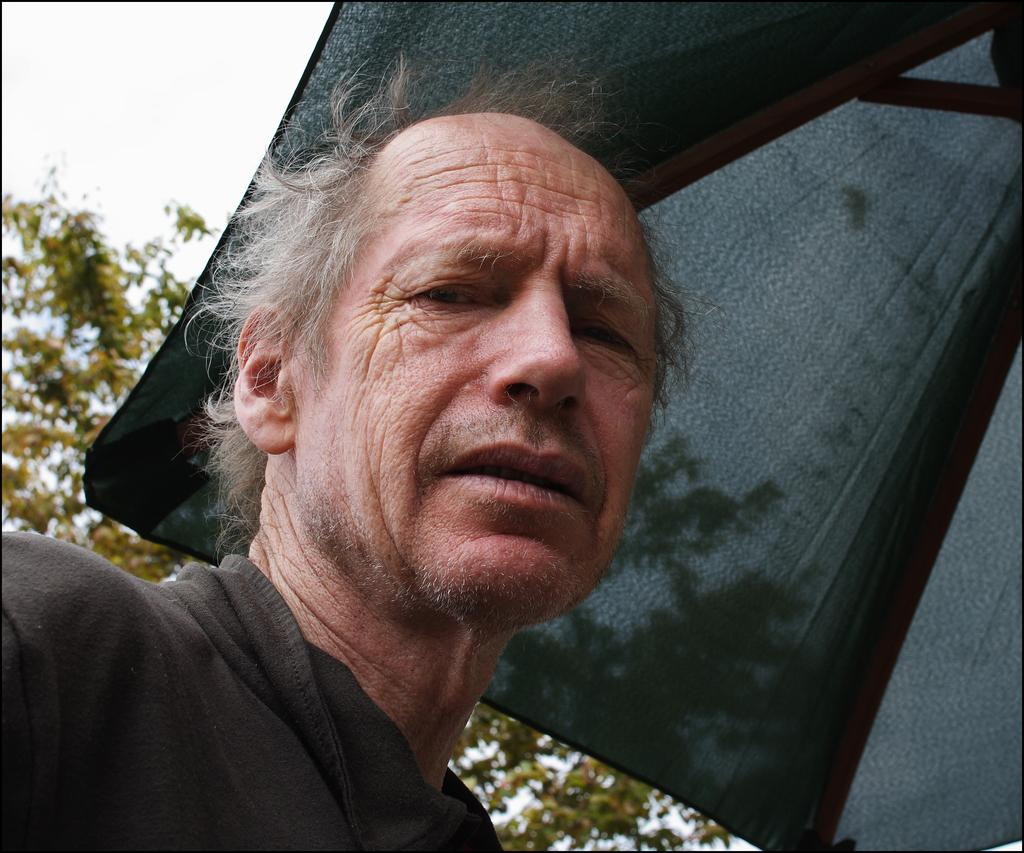Who or what is present in the image? There is a person in the image. What is on top of the person's head? There is a tent on top of the person's head. What can be seen in the background of the image? There are trees in the background of the image. Where is the oven located in the image? There is no oven present in the image. How many cattle can be seen grazing in the background of the image? There are no cattle present in the image; only trees can be seen in the background. 